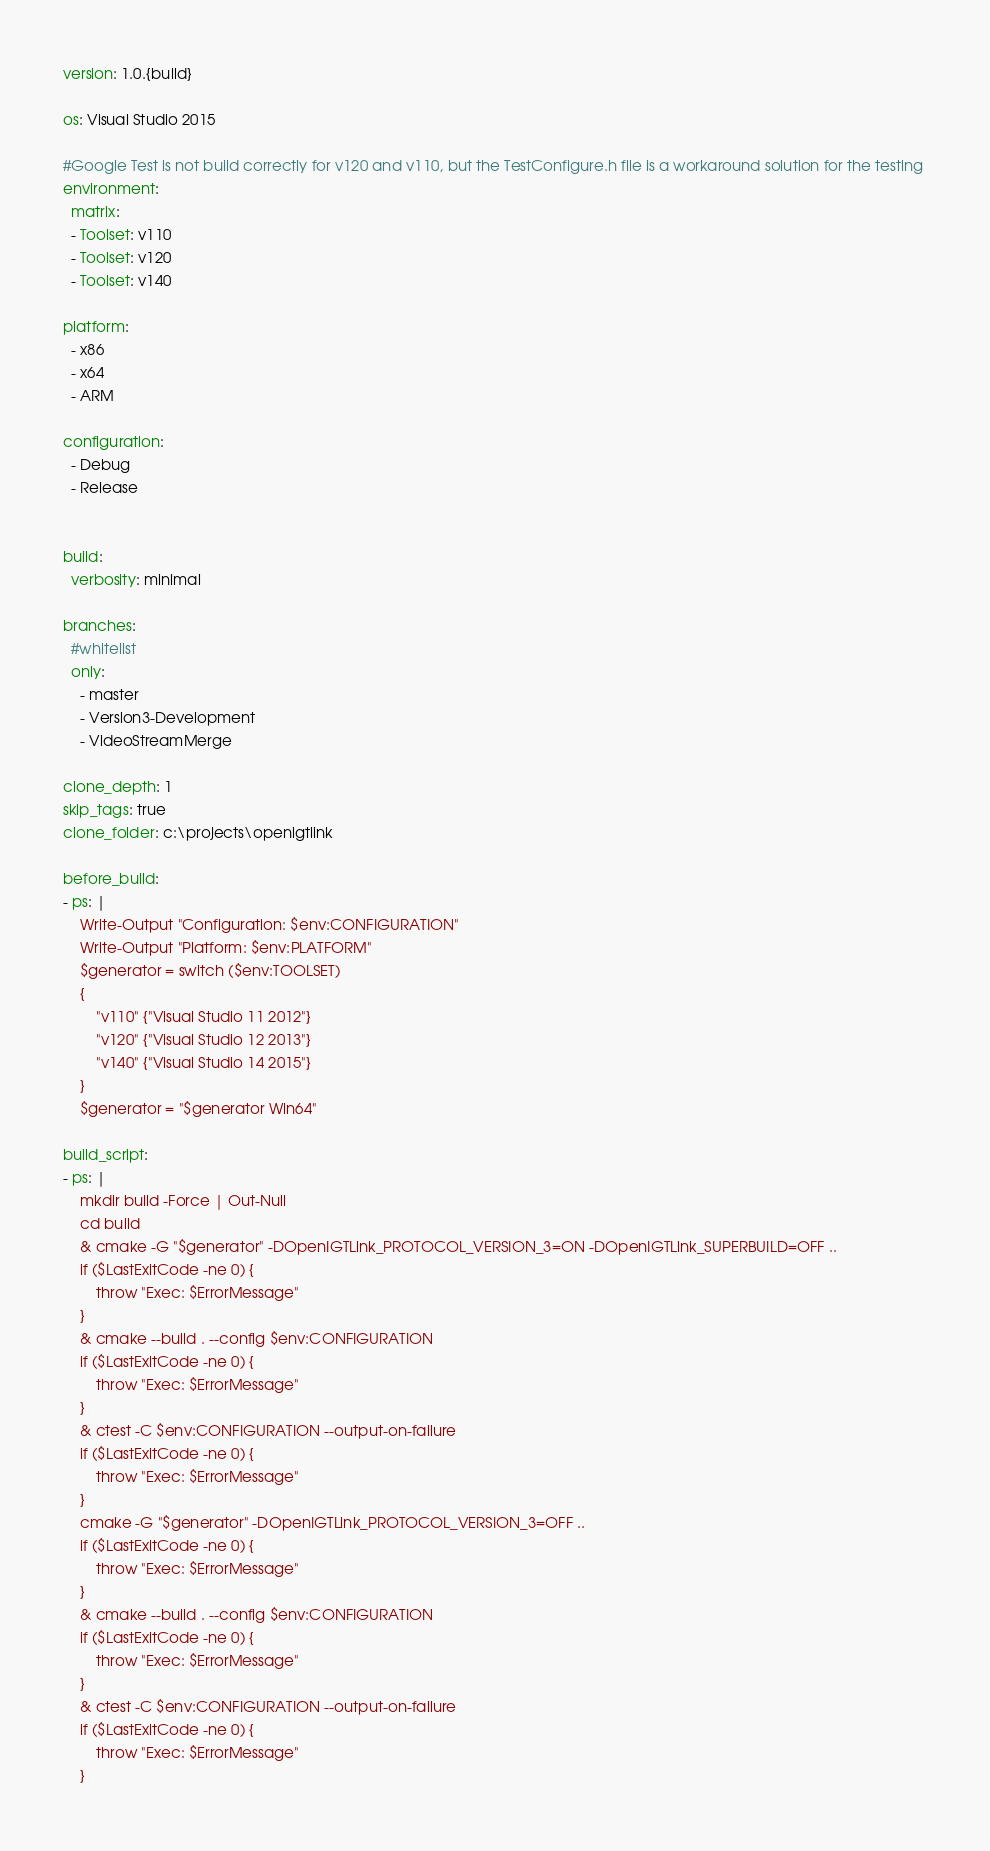Convert code to text. <code><loc_0><loc_0><loc_500><loc_500><_YAML_>version: 1.0.{build}

os: Visual Studio 2015

#Google Test is not build correctly for v120 and v110, but the TestConfigure.h file is a workaround solution for the testing 
environment:
  matrix:
  - Toolset: v110
  - Toolset: v120  
  - Toolset: v140
  
platform: 
  - x86
  - x64
  - ARM

configuration: 
  - Debug
  - Release
    

build:
  verbosity: minimal
  
branches:
  #whitelist
  only:
    - master
    - Version3-Development
    - VideoStreamMerge
      
clone_depth: 1
skip_tags: true
clone_folder: c:\projects\openigtlink
      
before_build:
- ps: |
    Write-Output "Configuration: $env:CONFIGURATION"
    Write-Output "Platform: $env:PLATFORM"
    $generator = switch ($env:TOOLSET)
    {
        "v110" {"Visual Studio 11 2012"}
        "v120" {"Visual Studio 12 2013"}
        "v140" {"Visual Studio 14 2015"}
    }
    $generator = "$generator Win64"

build_script:
- ps: |
    mkdir build -Force | Out-Null
    cd build
    & cmake -G "$generator" -DOpenIGTLink_PROTOCOL_VERSION_3=ON -DOpenIGTLink_SUPERBUILD=OFF ..
    if ($LastExitCode -ne 0) {
        throw "Exec: $ErrorMessage"
    }
    & cmake --build . --config $env:CONFIGURATION
    if ($LastExitCode -ne 0) {
        throw "Exec: $ErrorMessage"
    }
    & ctest -C $env:CONFIGURATION --output-on-failure
    if ($LastExitCode -ne 0) {
        throw "Exec: $ErrorMessage"
    }
    cmake -G "$generator" -DOpenIGTLink_PROTOCOL_VERSION_3=OFF ..
    if ($LastExitCode -ne 0) {
        throw "Exec: $ErrorMessage"
    }
    & cmake --build . --config $env:CONFIGURATION
    if ($LastExitCode -ne 0) {
        throw "Exec: $ErrorMessage"
    }
    & ctest -C $env:CONFIGURATION --output-on-failure
    if ($LastExitCode -ne 0) {
        throw "Exec: $ErrorMessage"
    }    
</code> 